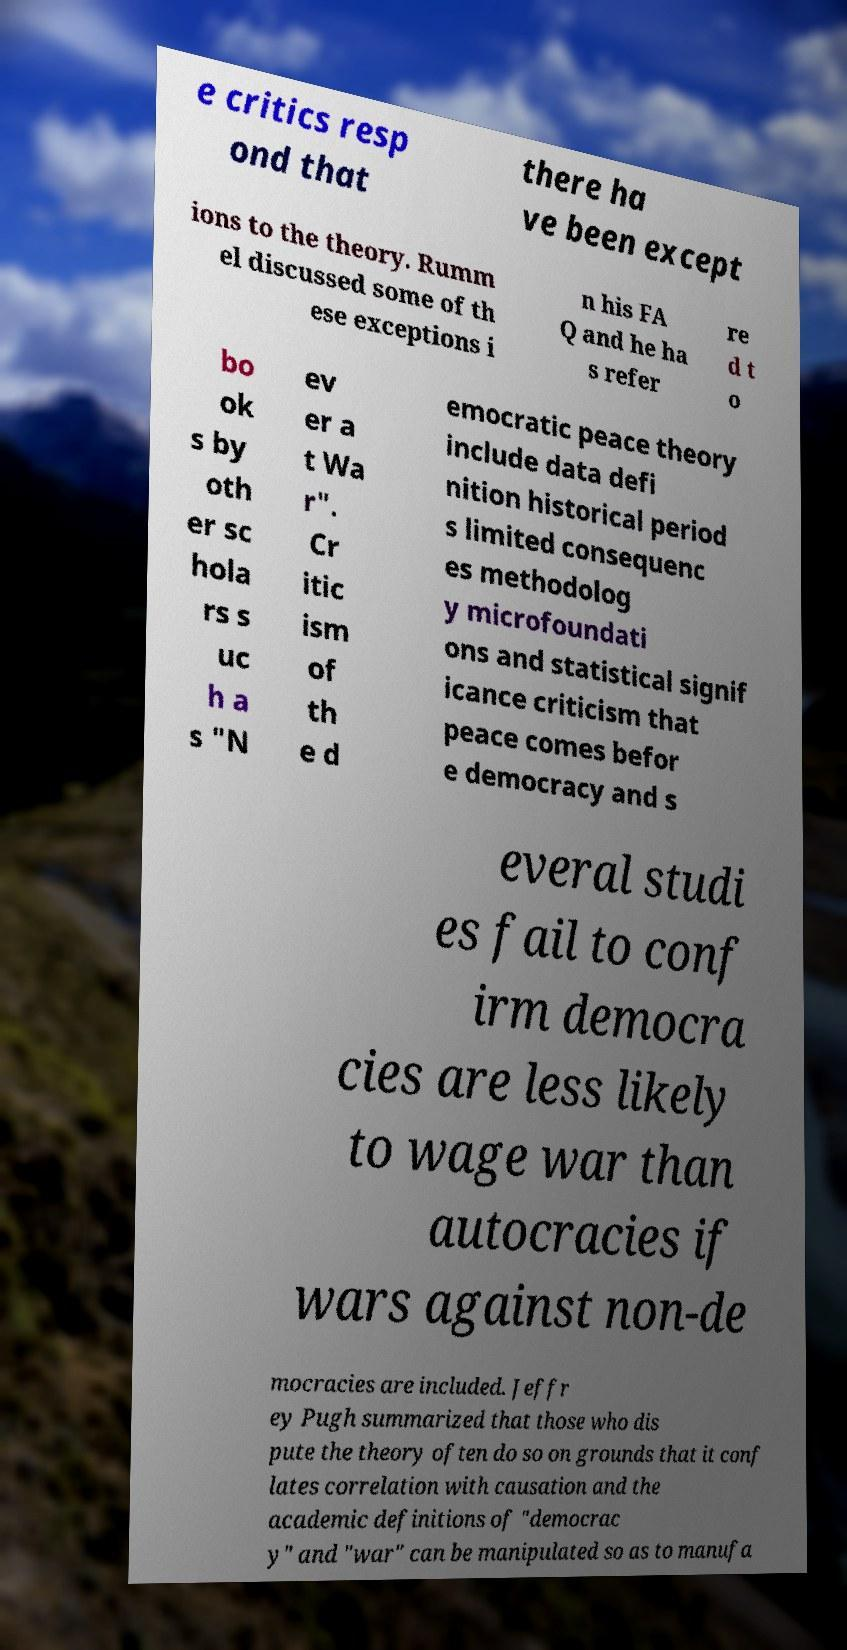Can you accurately transcribe the text from the provided image for me? e critics resp ond that there ha ve been except ions to the theory. Rumm el discussed some of th ese exceptions i n his FA Q and he ha s refer re d t o bo ok s by oth er sc hola rs s uc h a s "N ev er a t Wa r". Cr itic ism of th e d emocratic peace theory include data defi nition historical period s limited consequenc es methodolog y microfoundati ons and statistical signif icance criticism that peace comes befor e democracy and s everal studi es fail to conf irm democra cies are less likely to wage war than autocracies if wars against non-de mocracies are included. Jeffr ey Pugh summarized that those who dis pute the theory often do so on grounds that it conf lates correlation with causation and the academic definitions of "democrac y" and "war" can be manipulated so as to manufa 